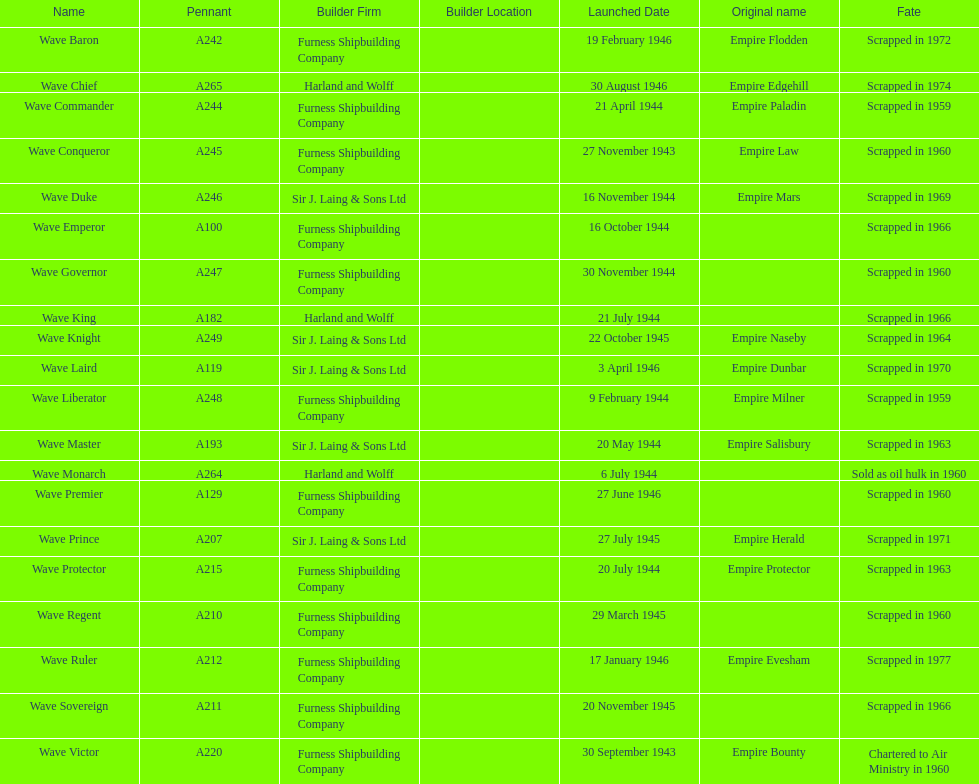Help me parse the entirety of this table. {'header': ['Name', 'Pennant', 'Builder Firm', 'Builder Location', 'Launched Date', 'Original name', 'Fate'], 'rows': [['Wave Baron', 'A242', 'Furness Shipbuilding Company', '', '19 February 1946', 'Empire Flodden', 'Scrapped in 1972'], ['Wave Chief', 'A265', 'Harland and Wolff', '', '30 August 1946', 'Empire Edgehill', 'Scrapped in 1974'], ['Wave Commander', 'A244', 'Furness Shipbuilding Company', '', '21 April 1944', 'Empire Paladin', 'Scrapped in 1959'], ['Wave Conqueror', 'A245', 'Furness Shipbuilding Company', '', '27 November 1943', 'Empire Law', 'Scrapped in 1960'], ['Wave Duke', 'A246', 'Sir J. Laing & Sons Ltd', '', '16 November 1944', 'Empire Mars', 'Scrapped in 1969'], ['Wave Emperor', 'A100', 'Furness Shipbuilding Company', '', '16 October 1944', '', 'Scrapped in 1966'], ['Wave Governor', 'A247', 'Furness Shipbuilding Company', '', '30 November 1944', '', 'Scrapped in 1960'], ['Wave King', 'A182', 'Harland and Wolff', '', '21 July 1944', '', 'Scrapped in 1966'], ['Wave Knight', 'A249', 'Sir J. Laing & Sons Ltd', '', '22 October 1945', 'Empire Naseby', 'Scrapped in 1964'], ['Wave Laird', 'A119', 'Sir J. Laing & Sons Ltd', '', '3 April 1946', 'Empire Dunbar', 'Scrapped in 1970'], ['Wave Liberator', 'A248', 'Furness Shipbuilding Company', '', '9 February 1944', 'Empire Milner', 'Scrapped in 1959'], ['Wave Master', 'A193', 'Sir J. Laing & Sons Ltd', '', '20 May 1944', 'Empire Salisbury', 'Scrapped in 1963'], ['Wave Monarch', 'A264', 'Harland and Wolff', '', '6 July 1944', '', 'Sold as oil hulk in 1960'], ['Wave Premier', 'A129', 'Furness Shipbuilding Company', '', '27 June 1946', '', 'Scrapped in 1960'], ['Wave Prince', 'A207', 'Sir J. Laing & Sons Ltd', '', '27 July 1945', 'Empire Herald', 'Scrapped in 1971'], ['Wave Protector', 'A215', 'Furness Shipbuilding Company', '', '20 July 1944', 'Empire Protector', 'Scrapped in 1963'], ['Wave Regent', 'A210', 'Furness Shipbuilding Company', '', '29 March 1945', '', 'Scrapped in 1960'], ['Wave Ruler', 'A212', 'Furness Shipbuilding Company', '', '17 January 1946', 'Empire Evesham', 'Scrapped in 1977'], ['Wave Sovereign', 'A211', 'Furness Shipbuilding Company', '', '20 November 1945', '', 'Scrapped in 1966'], ['Wave Victor', 'A220', 'Furness Shipbuilding Company', '', '30 September 1943', 'Empire Bounty', 'Chartered to Air Ministry in 1960']]} What is the name of the last ship that was scrapped? Wave Ruler. 